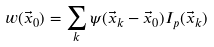<formula> <loc_0><loc_0><loc_500><loc_500>w ( \vec { x } _ { 0 } ) = \sum _ { k } \psi ( \vec { x } _ { k } - \vec { x } _ { 0 } ) I _ { p } ( \vec { x } _ { k } )</formula> 